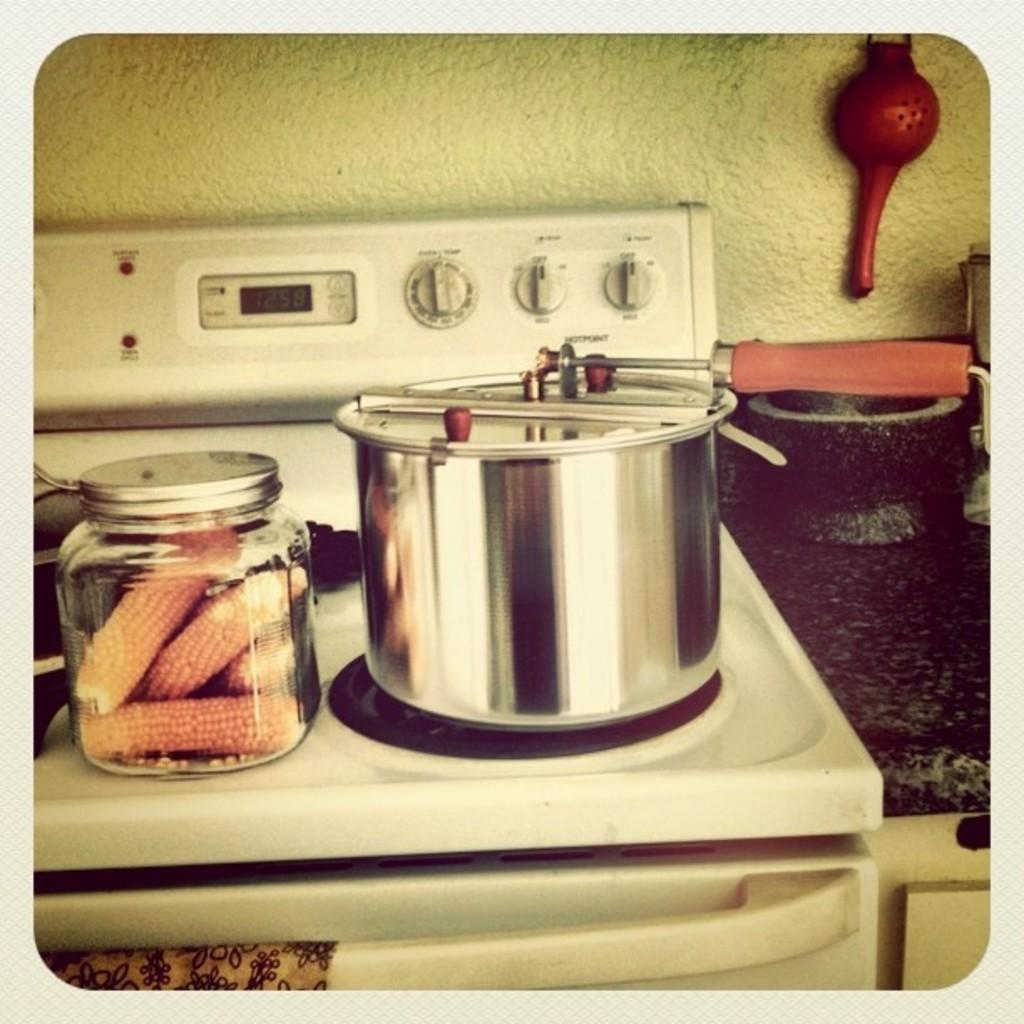Provide a one-sentence caption for the provided image. A stove with the time of 12:58 displayed. 